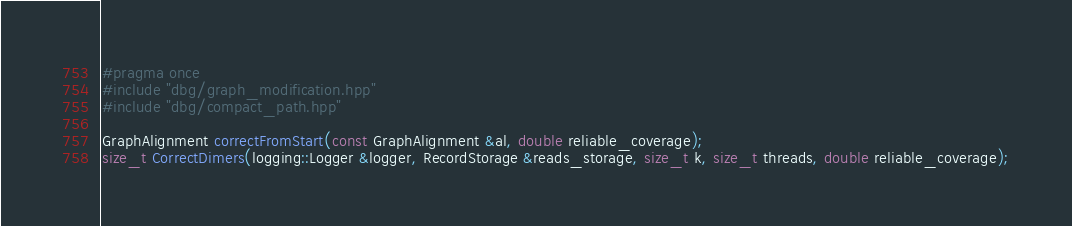<code> <loc_0><loc_0><loc_500><loc_500><_C++_>#pragma once
#include "dbg/graph_modification.hpp"
#include "dbg/compact_path.hpp"

GraphAlignment correctFromStart(const GraphAlignment &al, double reliable_coverage);
size_t CorrectDimers(logging::Logger &logger, RecordStorage &reads_storage, size_t k, size_t threads, double reliable_coverage);</code> 